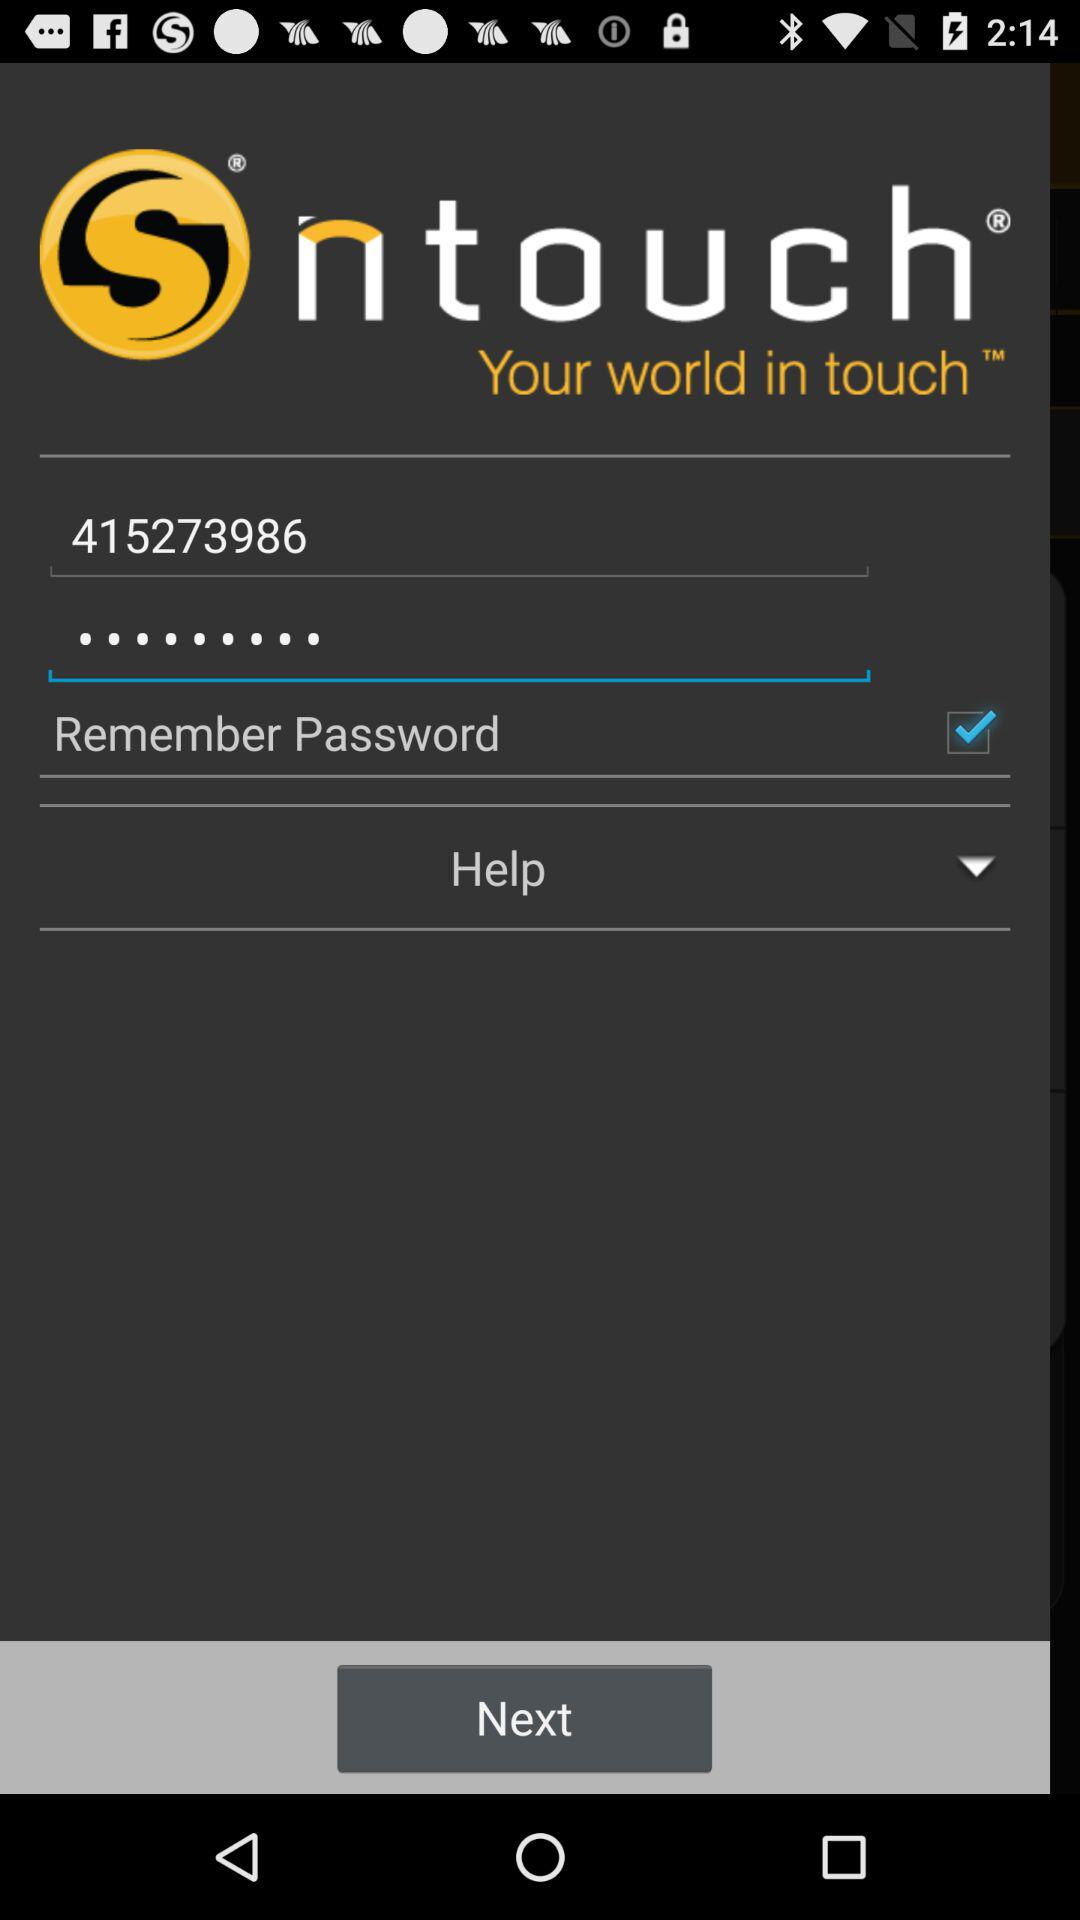What is the user ID? The user ID is 415273986. 